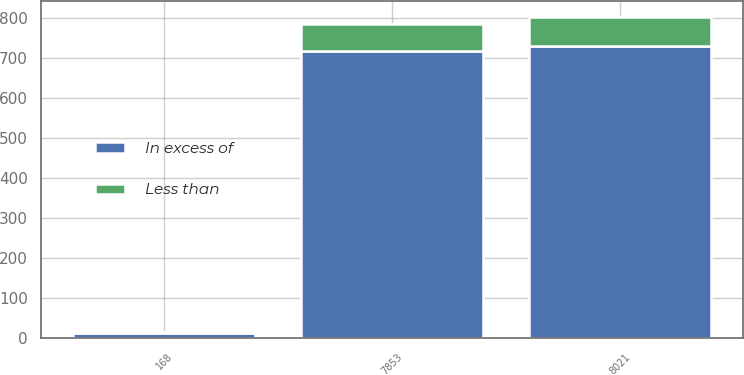Convert chart to OTSL. <chart><loc_0><loc_0><loc_500><loc_500><stacked_bar_chart><ecel><fcel>7853<fcel>168<fcel>8021<nl><fcel>Less than<fcel>68.9<fcel>4.5<fcel>73.4<nl><fcel>In excess of<fcel>716.4<fcel>12.3<fcel>728.7<nl></chart> 